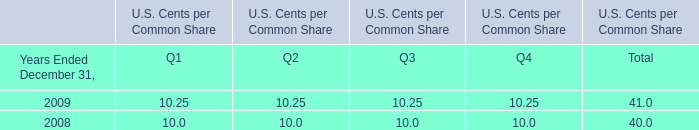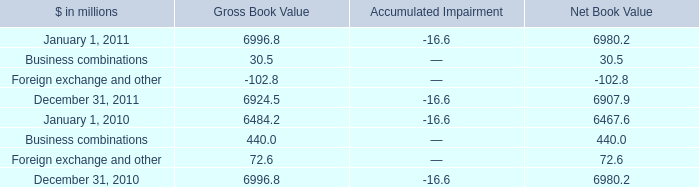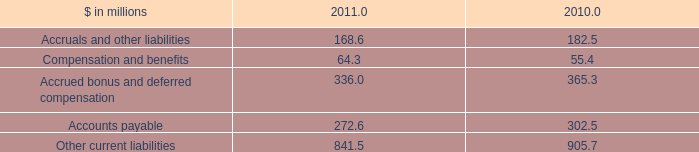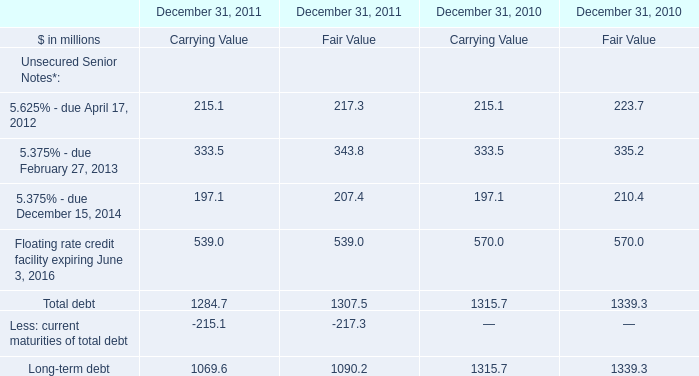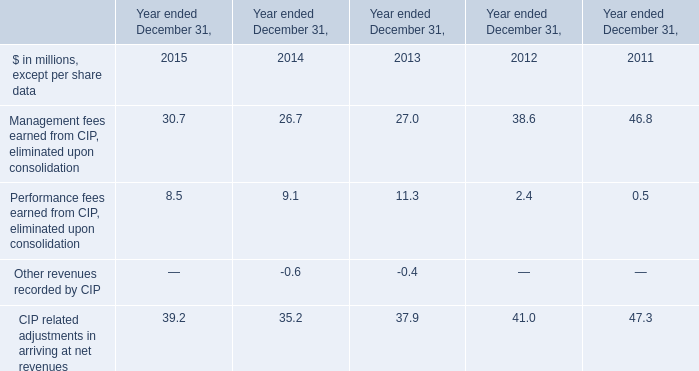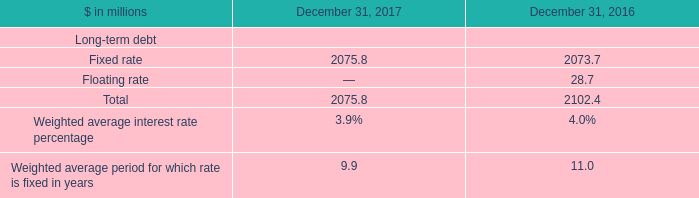When is Gross Book Value in terms of Business combinations larger? 
Answer: 2010. 